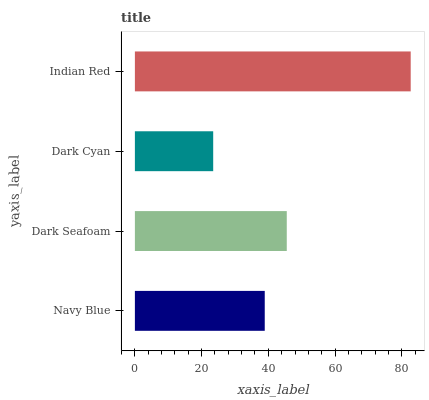Is Dark Cyan the minimum?
Answer yes or no. Yes. Is Indian Red the maximum?
Answer yes or no. Yes. Is Dark Seafoam the minimum?
Answer yes or no. No. Is Dark Seafoam the maximum?
Answer yes or no. No. Is Dark Seafoam greater than Navy Blue?
Answer yes or no. Yes. Is Navy Blue less than Dark Seafoam?
Answer yes or no. Yes. Is Navy Blue greater than Dark Seafoam?
Answer yes or no. No. Is Dark Seafoam less than Navy Blue?
Answer yes or no. No. Is Dark Seafoam the high median?
Answer yes or no. Yes. Is Navy Blue the low median?
Answer yes or no. Yes. Is Dark Cyan the high median?
Answer yes or no. No. Is Indian Red the low median?
Answer yes or no. No. 